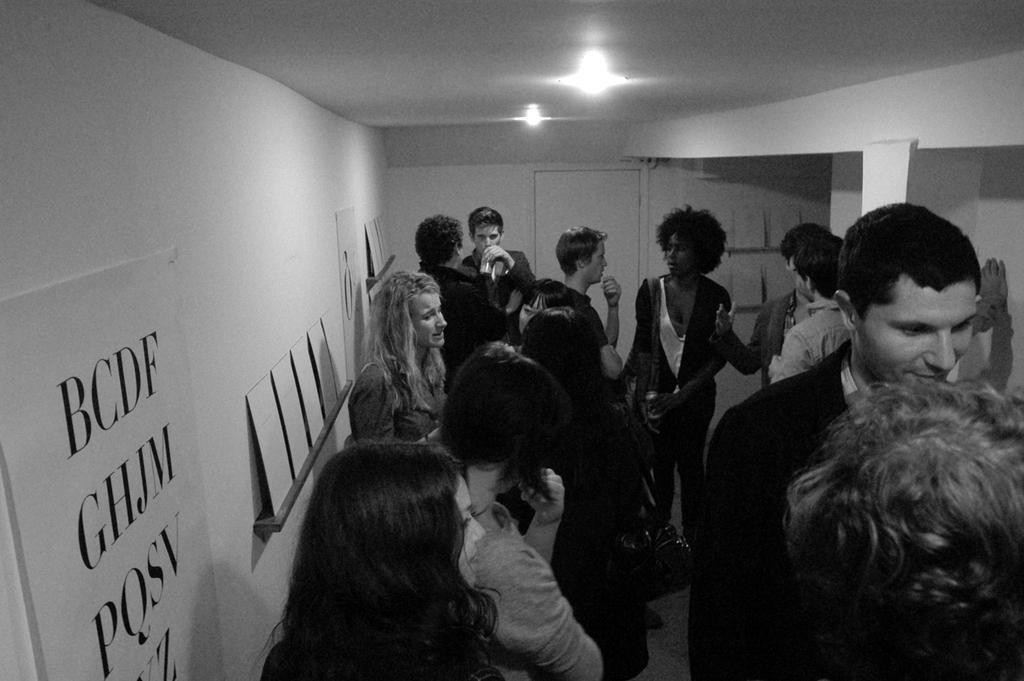Could you give a brief overview of what you see in this image? In this picture we can see a group of people standing on the floor, door, banner, wall, lights and in the background we can see boards. 